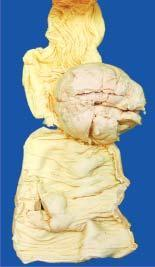what is ulcerated?
Answer the question using a single word or phrase. Covering mucosa 